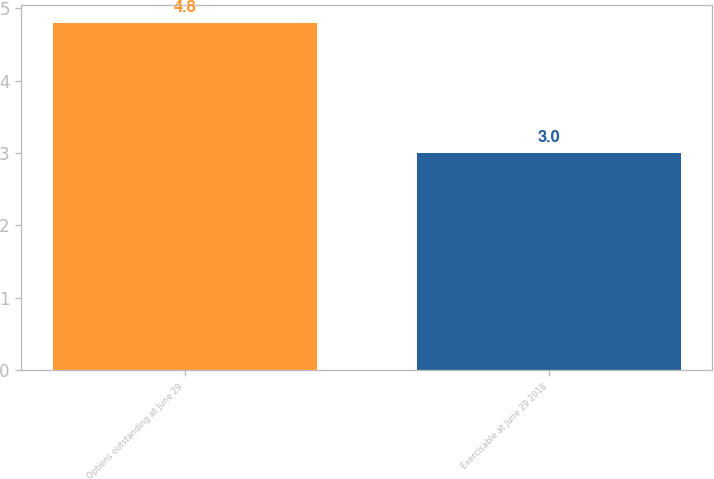Convert chart to OTSL. <chart><loc_0><loc_0><loc_500><loc_500><bar_chart><fcel>Options outstanding at June 29<fcel>Exercisable at June 29 2018<nl><fcel>4.8<fcel>3<nl></chart> 